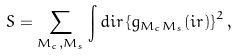<formula> <loc_0><loc_0><loc_500><loc_500>S = \sum _ { M _ { c } , M _ { s } } \int d { i r } \left \{ g _ { M _ { c } M _ { s } } ( { i r } ) \right \} ^ { 2 } ,</formula> 